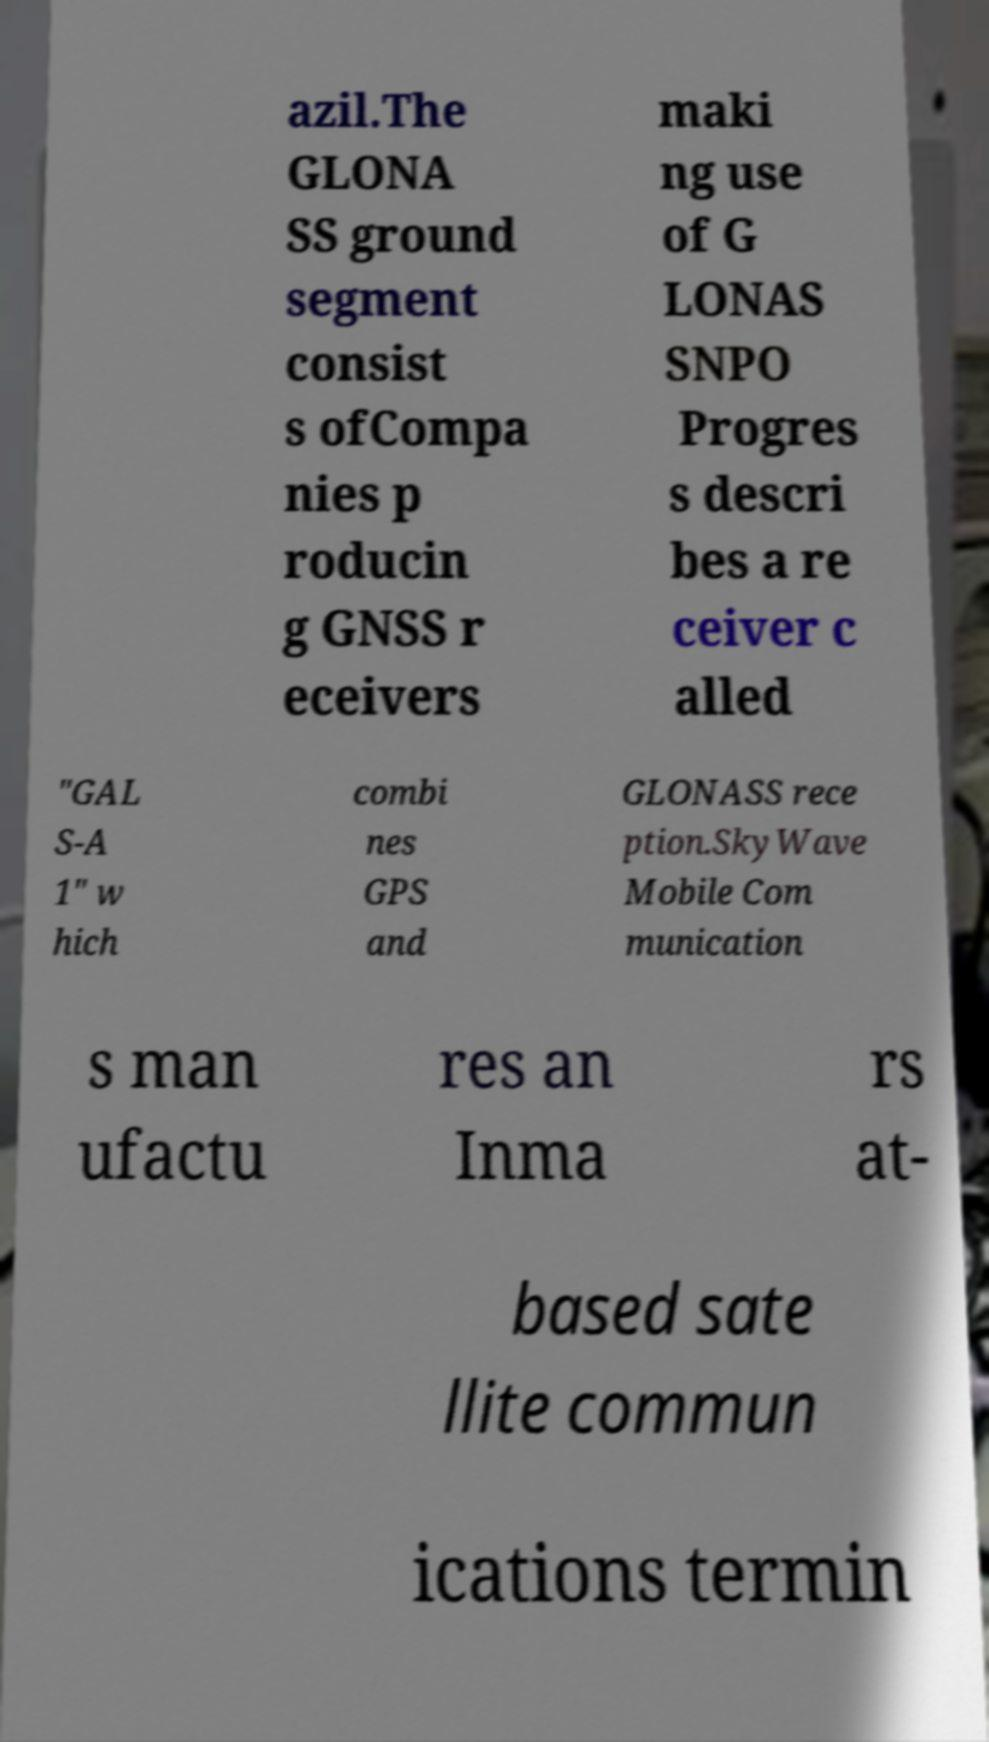Can you read and provide the text displayed in the image?This photo seems to have some interesting text. Can you extract and type it out for me? azil.The GLONA SS ground segment consist s ofCompa nies p roducin g GNSS r eceivers maki ng use of G LONAS SNPO Progres s descri bes a re ceiver c alled "GAL S-A 1" w hich combi nes GPS and GLONASS rece ption.SkyWave Mobile Com munication s man ufactu res an Inma rs at- based sate llite commun ications termin 